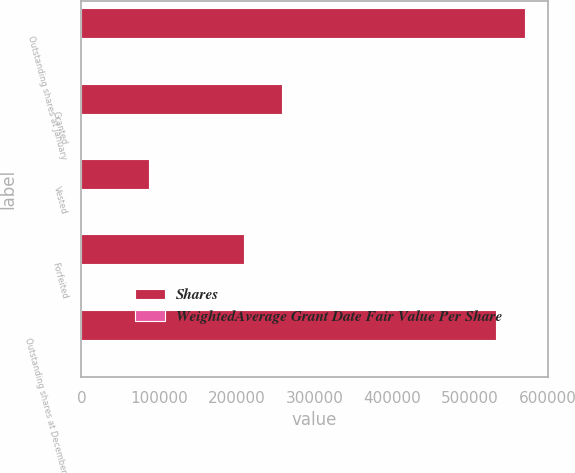Convert chart. <chart><loc_0><loc_0><loc_500><loc_500><stacked_bar_chart><ecel><fcel>Outstanding shares at January<fcel>Granted<fcel>Vested<fcel>Forfeited<fcel>Outstanding shares at December<nl><fcel>Shares<fcel>571551<fcel>258808<fcel>86964<fcel>209244<fcel>534151<nl><fcel>WeightedAverage Grant Date Fair Value Per Share<fcel>82.02<fcel>72.28<fcel>67.16<fcel>72.12<fcel>83.6<nl></chart> 